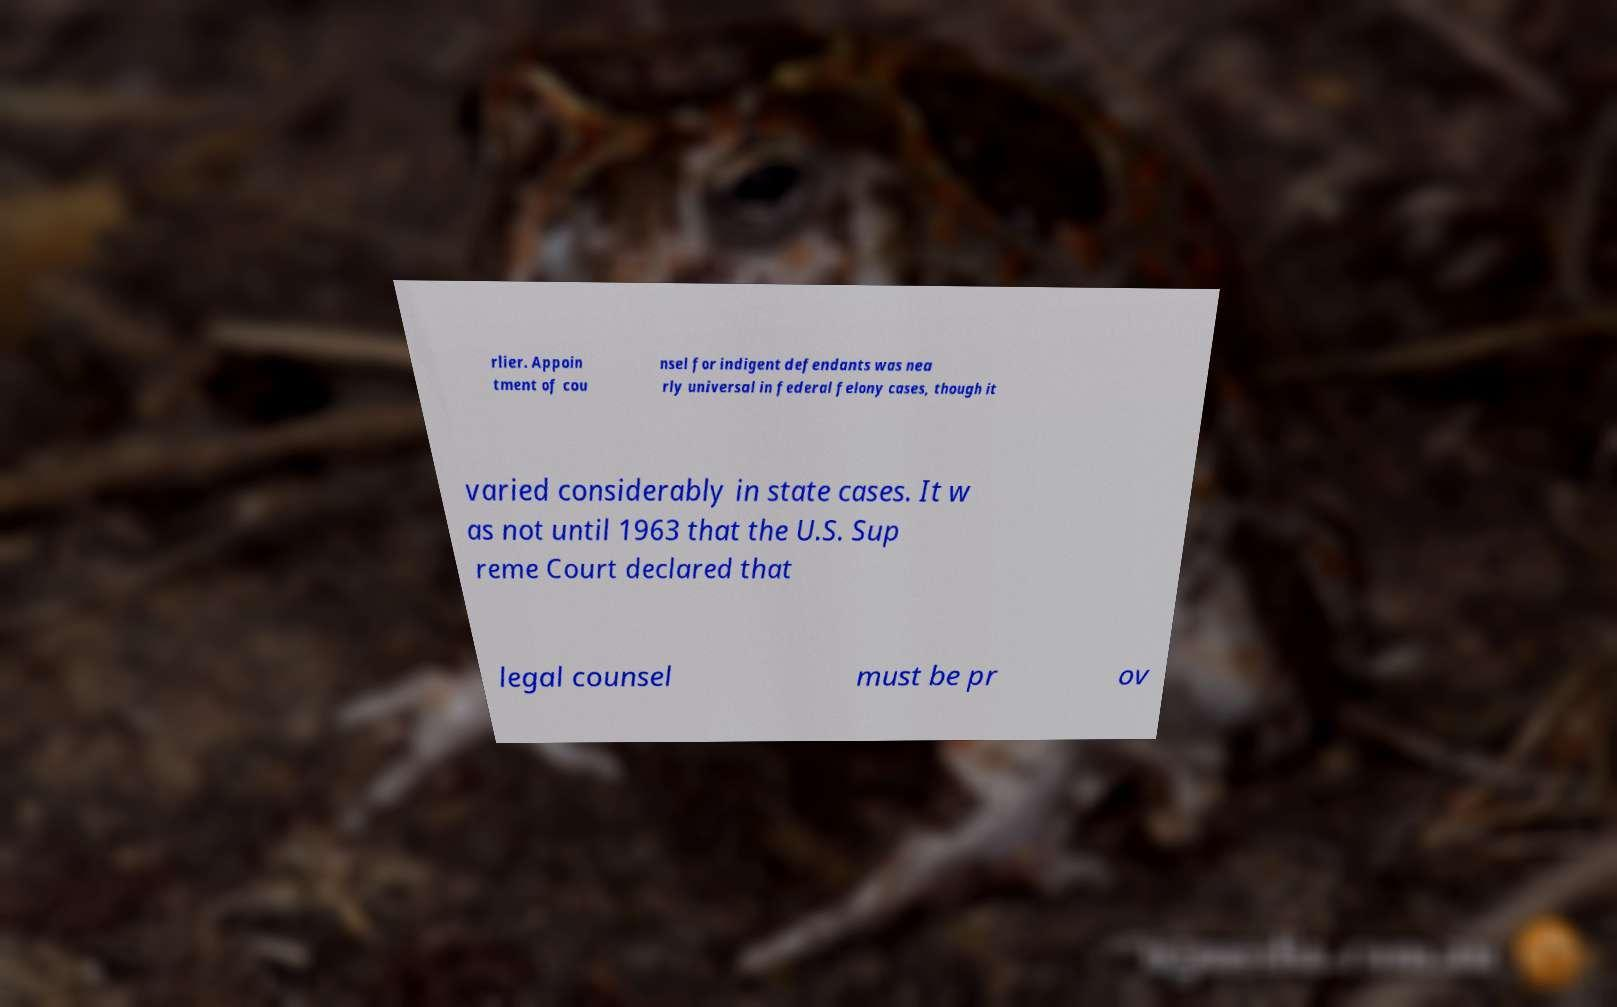Could you extract and type out the text from this image? rlier. Appoin tment of cou nsel for indigent defendants was nea rly universal in federal felony cases, though it varied considerably in state cases. It w as not until 1963 that the U.S. Sup reme Court declared that legal counsel must be pr ov 